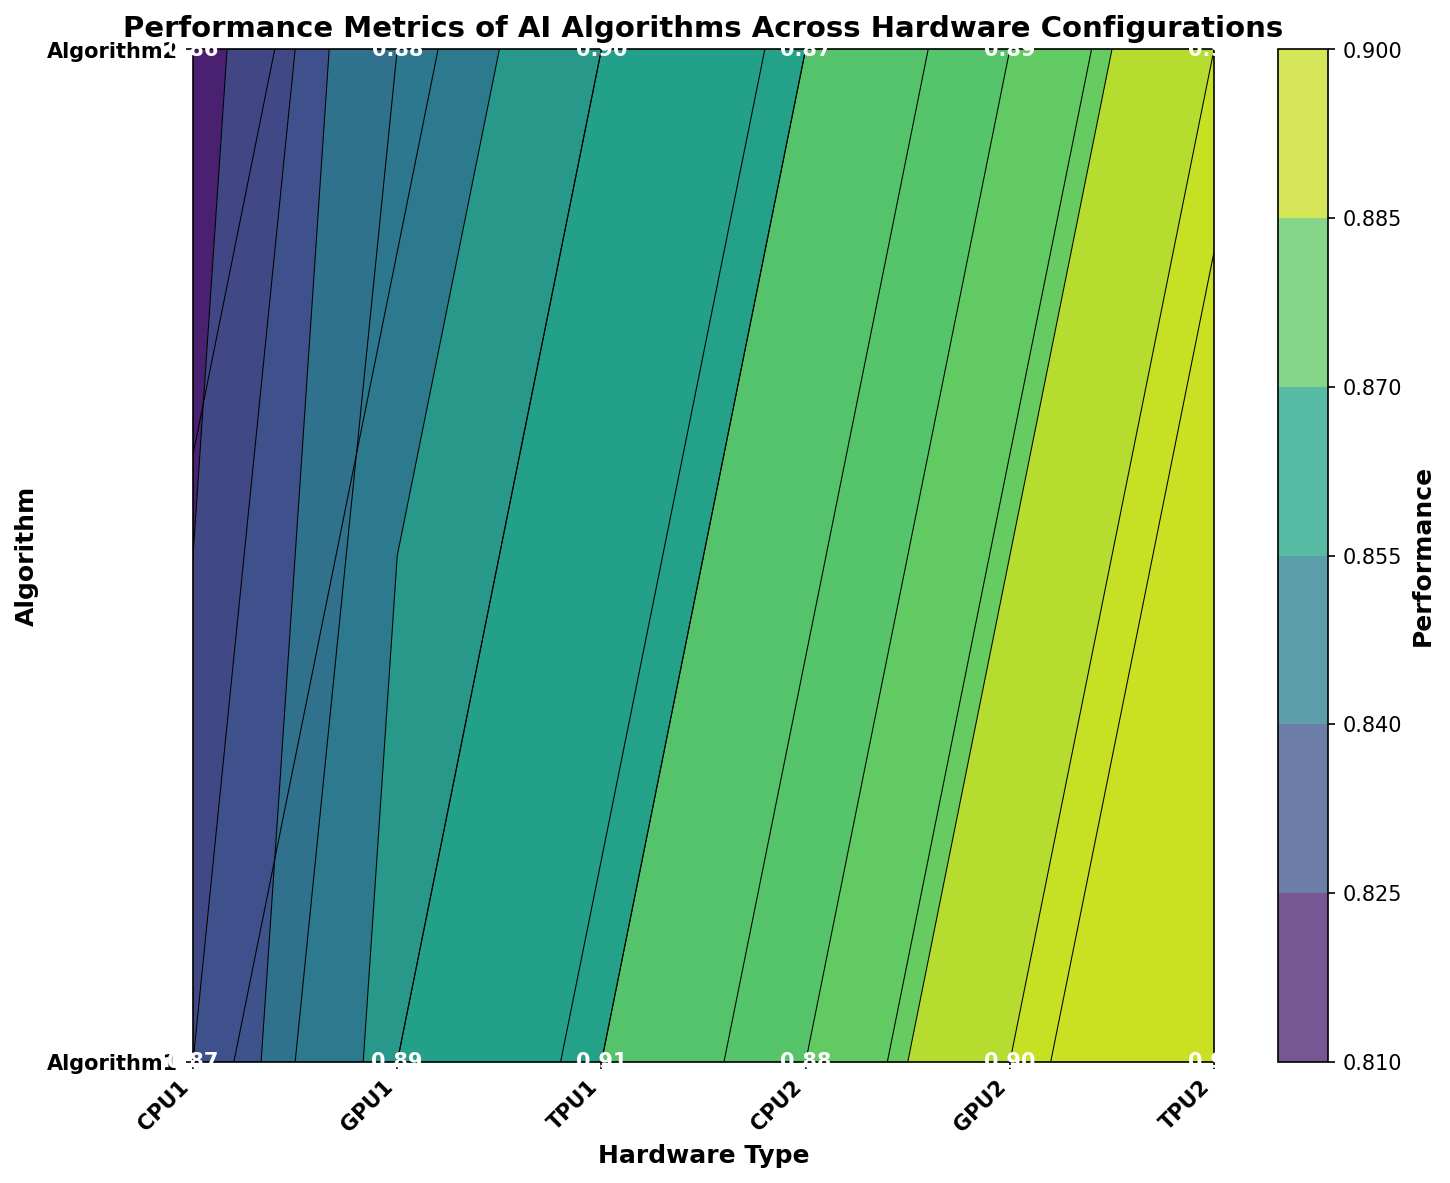what is the accuracy of Algorithm1 when executed on TPU1? The visual representation shows the performance metrics clearly. Locate the intersection of the 'Algorithm1' row and 'TPU1' column in the contour plot.
Answer: 0.91 which hardware type offers the best recall for Algorithm2? To answer this question, compare the recall values for Algorithm2 across the different hardware types plotted. Identify the highest value.
Answer: TPU2 how much higher is the accuracy of Algorithm1 on GPU1 compared to CPU1? Determine the accuracy values for Algorithm1 on GPU1 and CPU1, then subtract the CPU1 value from the GPU1 value.
Answer: 0.02 does Algorithm1 or Algorithm2 have better precision on GPU2? Compare the precision values of both Algorithms on GPU2 as shown in the figure to determine which one is higher.
Answer: Algorithm1 which algorithm shows a consistent increase in precision across all hardware types? Observe the trend in precision for each algorithm across hardware types. Check if the values steadily increase for any algorithm.
Answer: Algorithm1 on which hardware does Algorithm2 show the minimum recall? Identify the recall values of Algorithm2 for all hardware and find the one with the lowest value.
Answer: CPU1 compare the average accuracy of Algorithm1 on CPU2 and GPU2. Calculate the average of the accuracy values for Algorithm1 on CPU2 and GPU2 separately, then compare them.
Answer: Same (Both 0.90) what is the precision difference between Algorithm1 and Algorithm2 on TPU2? Find the precision values for both algorithms on TPU2 and then subtract Algorithm2’s precision from Algorithm1’s precision
Answer: 0.01 which metric has the least variance for Algorithm1 across all hardware? For each metric (Accuracy, Precision, Recall) of Algorithm1, calculate the variance across hardware and identify the one with the lowest variance.
Answer: Accuracy how does the recall of Algorithm2 vary across CPU1, GPU1, and TPU1? Track the recall values for Algorithm2 on CPU1, GPU1, and TPU1; note whether it increases or decreases. It consistently increases across these hardware types.
Answer: Increases 